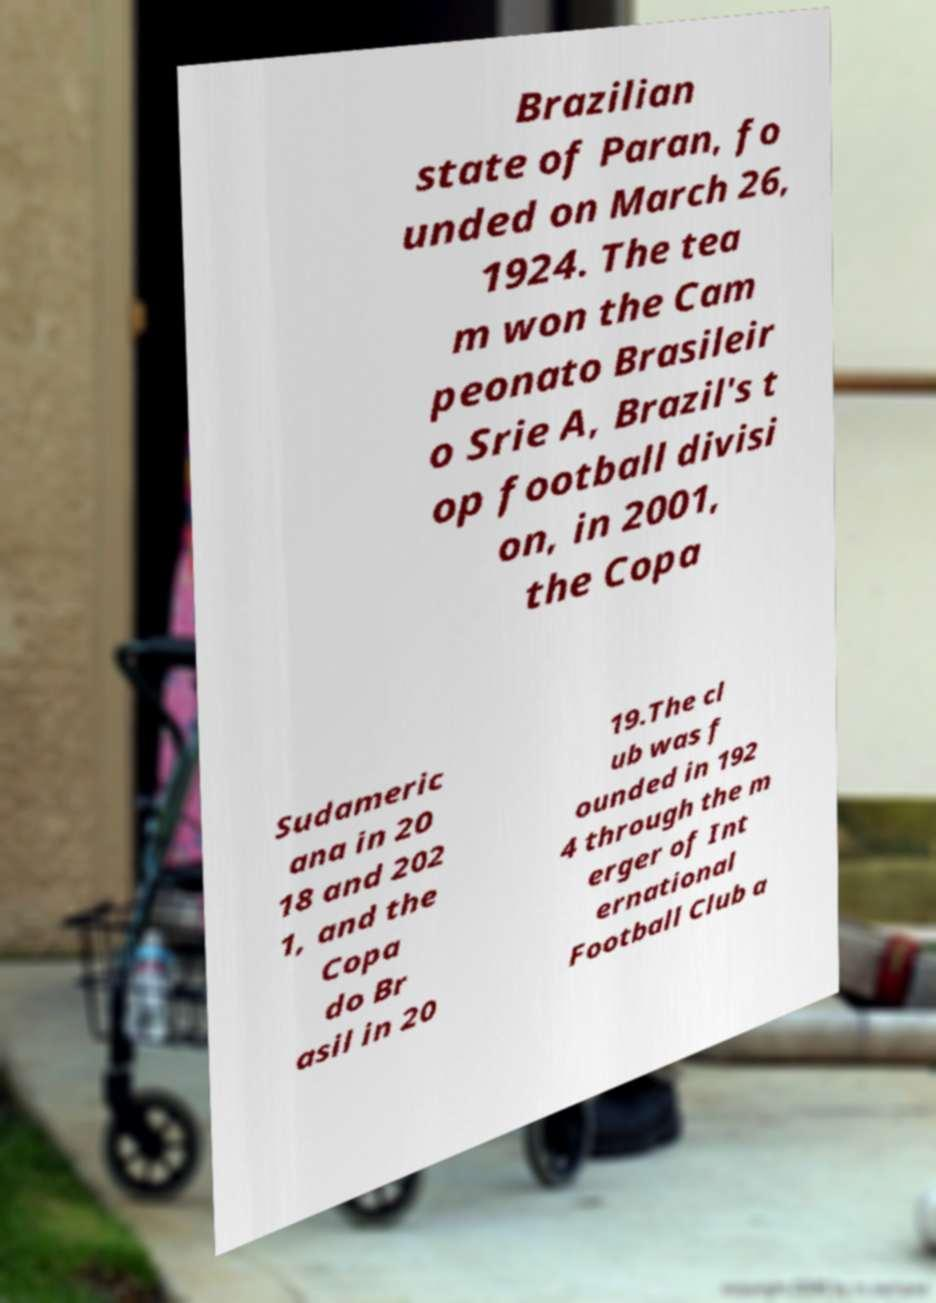Please identify and transcribe the text found in this image. Brazilian state of Paran, fo unded on March 26, 1924. The tea m won the Cam peonato Brasileir o Srie A, Brazil's t op football divisi on, in 2001, the Copa Sudameric ana in 20 18 and 202 1, and the Copa do Br asil in 20 19.The cl ub was f ounded in 192 4 through the m erger of Int ernational Football Club a 